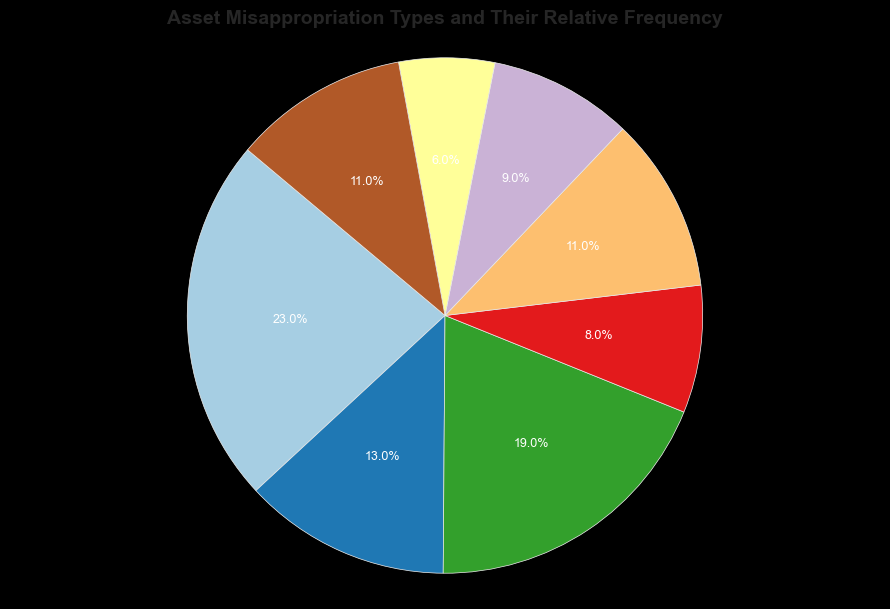Which asset misappropriation type has the highest frequency? The pie chart shows the categories and their relative frequencies. The segment labeled 'Billing Schemes' has the highest percentage (23%).
Answer: Billing Schemes Which type has the lowest occurrence, and what is its frequency? By examining the pie chart, the smallest segment is labeled 'Cash on Hand Misappropriations' with 6%.
Answer: Cash on Hand Misappropriations, 6% How do the frequencies of Check and Payment Tampering and Expense Reimbursement Schemes compare? The pie chart shows that 'Check and Payment Tampering' has 19% and 'Expense Reimbursement Schemes' has 13%. Check and Payment Tampering is greater than Expense Reimbursement Schemes.
Answer: Check and Payment Tampering > Expense Reimbursement Schemes What is the combined frequency of all cash-related misappropriations (Cash Larceny, Skimming, and Cash on Hand Misappropriations)? Add the percentages for 'Cash Larceny' (11%), 'Skimming' (9%), and 'Cash on Hand Misappropriations' (6%): 11 + 9 + 6 = 26%.
Answer: 26% How much larger is the frequency of Billing Schemes compared to Payroll Schemes? Subtract the percentage of 'Payroll Schemes' (8%) from 'Billing Schemes' (23%): 23 - 8 = 15%.
Answer: 15% Which non-cash misappropriation types are shown, and what are their frequencies? The pie chart indicates two non-cash misappropriation types: 'Non-Cash Misappropriations' with 11% and 'Expense Reimbursement Schemes' with 13%.
Answer: Non-Cash Misappropriations: 11%, Expense Reimbursement Schemes: 13% What is the average frequency of Cash Larceny, Skimming, and Non-Cash Misappropriations? Add their percentages (11% + 9% + 11%) and divide by 3: (11 + 9 + 11)/3 = 10.33%.
Answer: 10.33% What is the main color associated with the highest frequency type (Billing Schemes)? The color palette used assigns unique colors to each segment, and the 'Billing Schemes' segment appears as one of the lighter shades in the pie chart. This would need closer visual inspection to identify the exact color.
Answer: Light shade (depends on actual plot) 